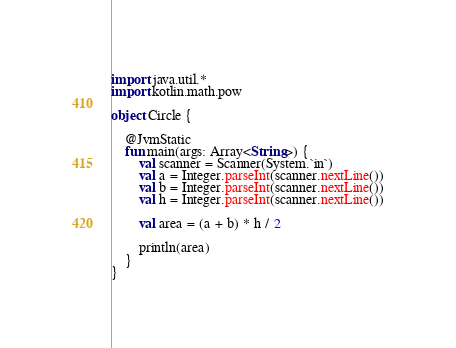Convert code to text. <code><loc_0><loc_0><loc_500><loc_500><_Kotlin_>import java.util.*
import kotlin.math.pow

object Circle {

    @JvmStatic
    fun main(args: Array<String>) {
        val scanner = Scanner(System.`in`)
        val a = Integer.parseInt(scanner.nextLine())
        val b = Integer.parseInt(scanner.nextLine())
        val h = Integer.parseInt(scanner.nextLine())

        val area = (a + b) * h / 2

        println(area)
    }
}
</code> 